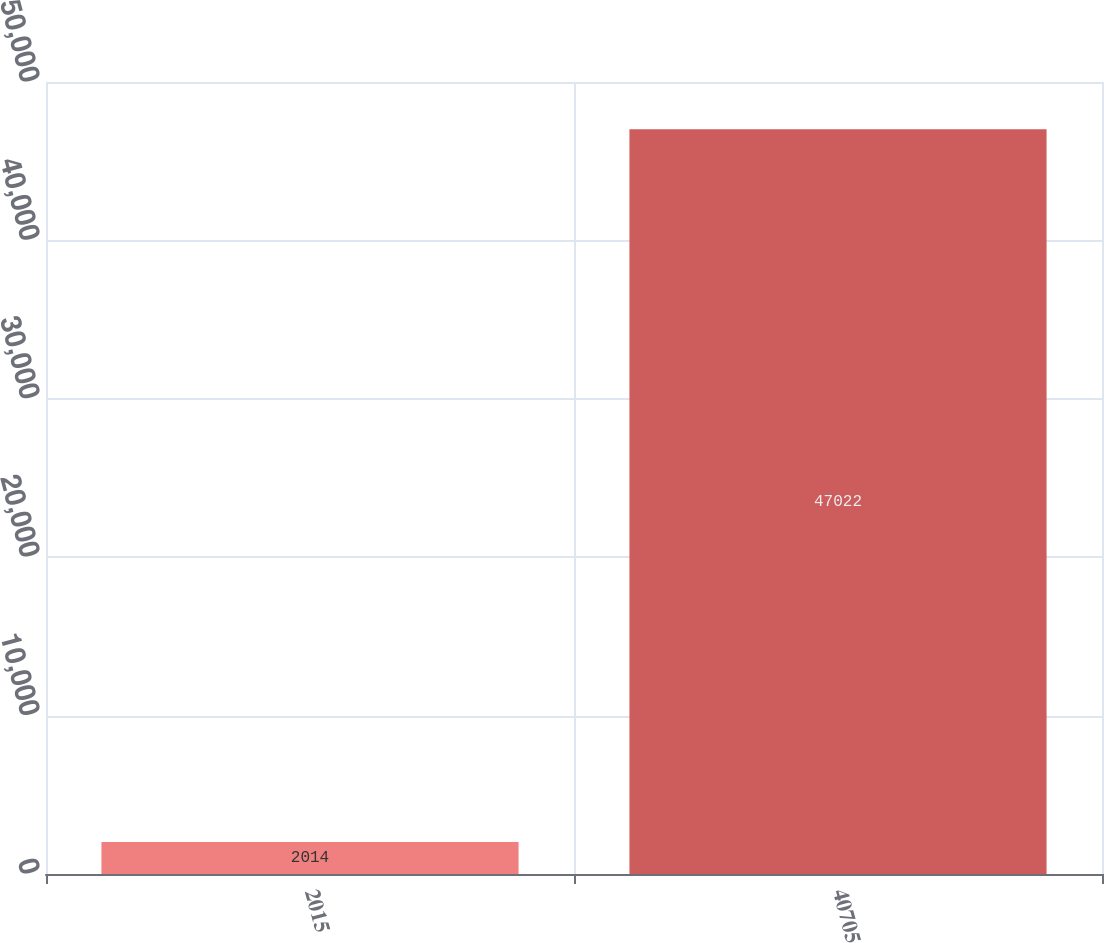Convert chart to OTSL. <chart><loc_0><loc_0><loc_500><loc_500><bar_chart><fcel>2015<fcel>40705<nl><fcel>2014<fcel>47022<nl></chart> 